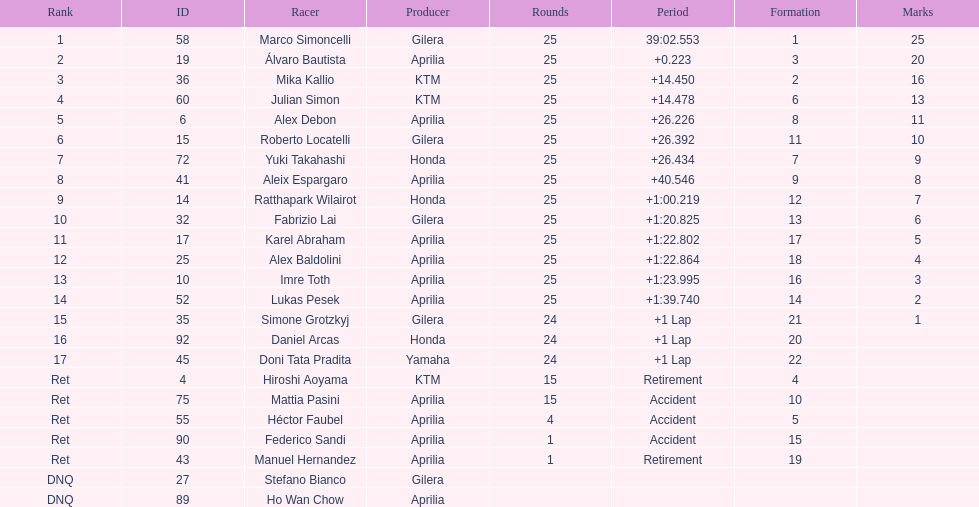Who perfomed the most number of laps, marco simoncelli or hiroshi aoyama? Marco Simoncelli. 